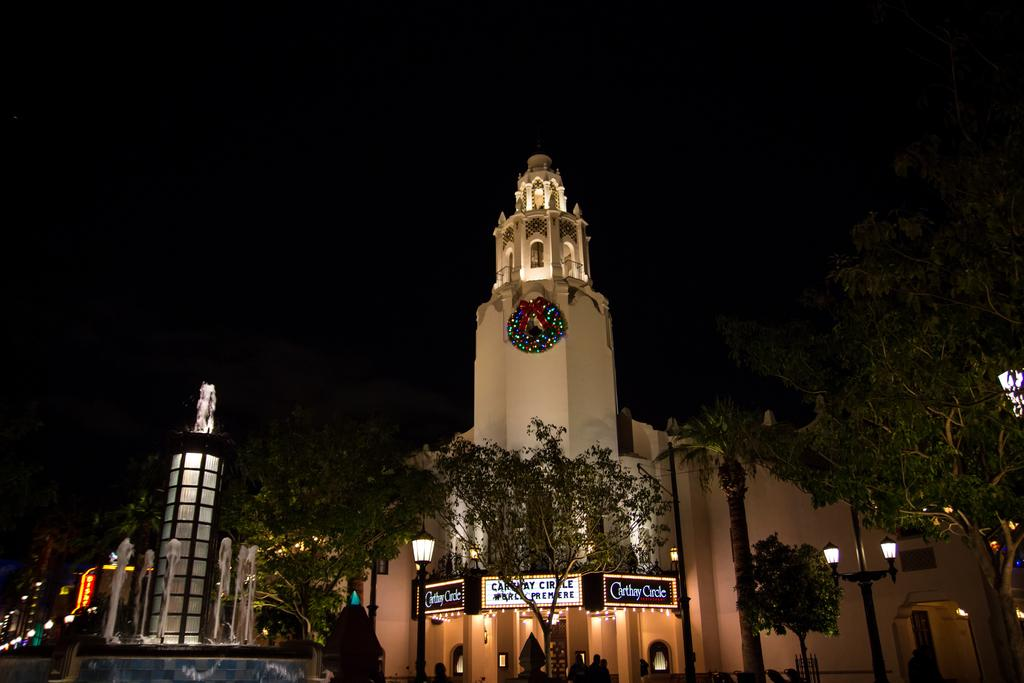What type of vegetation can be seen in the image? There are trees in the image. What structures are present in the image? There are poles and a building in the image. What is the color of the background in the image? The background of the image is dark. What can be found in the bottom left of the image? There is a fountain in the bottom left of the image. What types of toys are scattered around the trees in the image? There are no toys present in the image; it features trees, poles, a building, a dark background, and a fountain in the bottom left. How does the fountain drop water in the image? The image does not show the fountain in action, so it is not possible to determine how it drops water. 